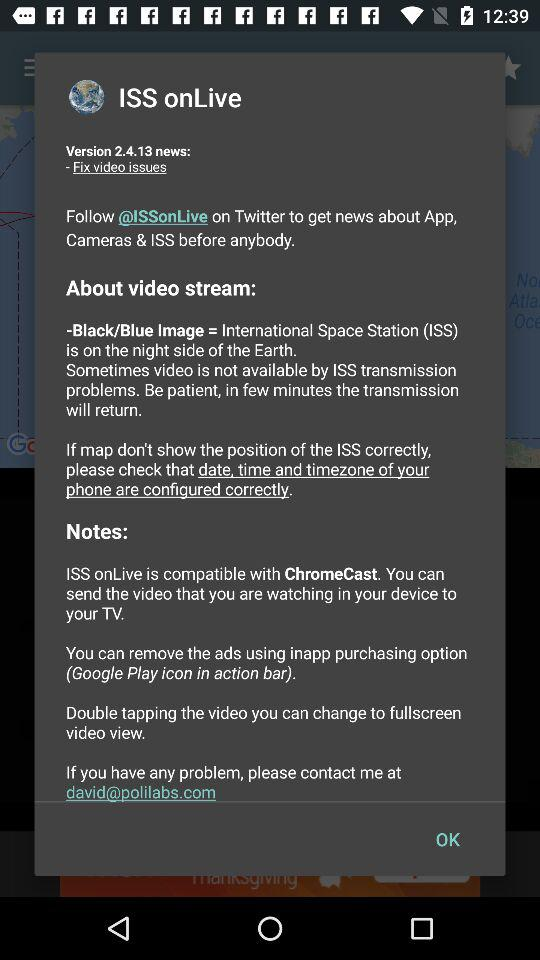How much does it cost to remove the ads?
When the provided information is insufficient, respond with <no answer>. <no answer> 